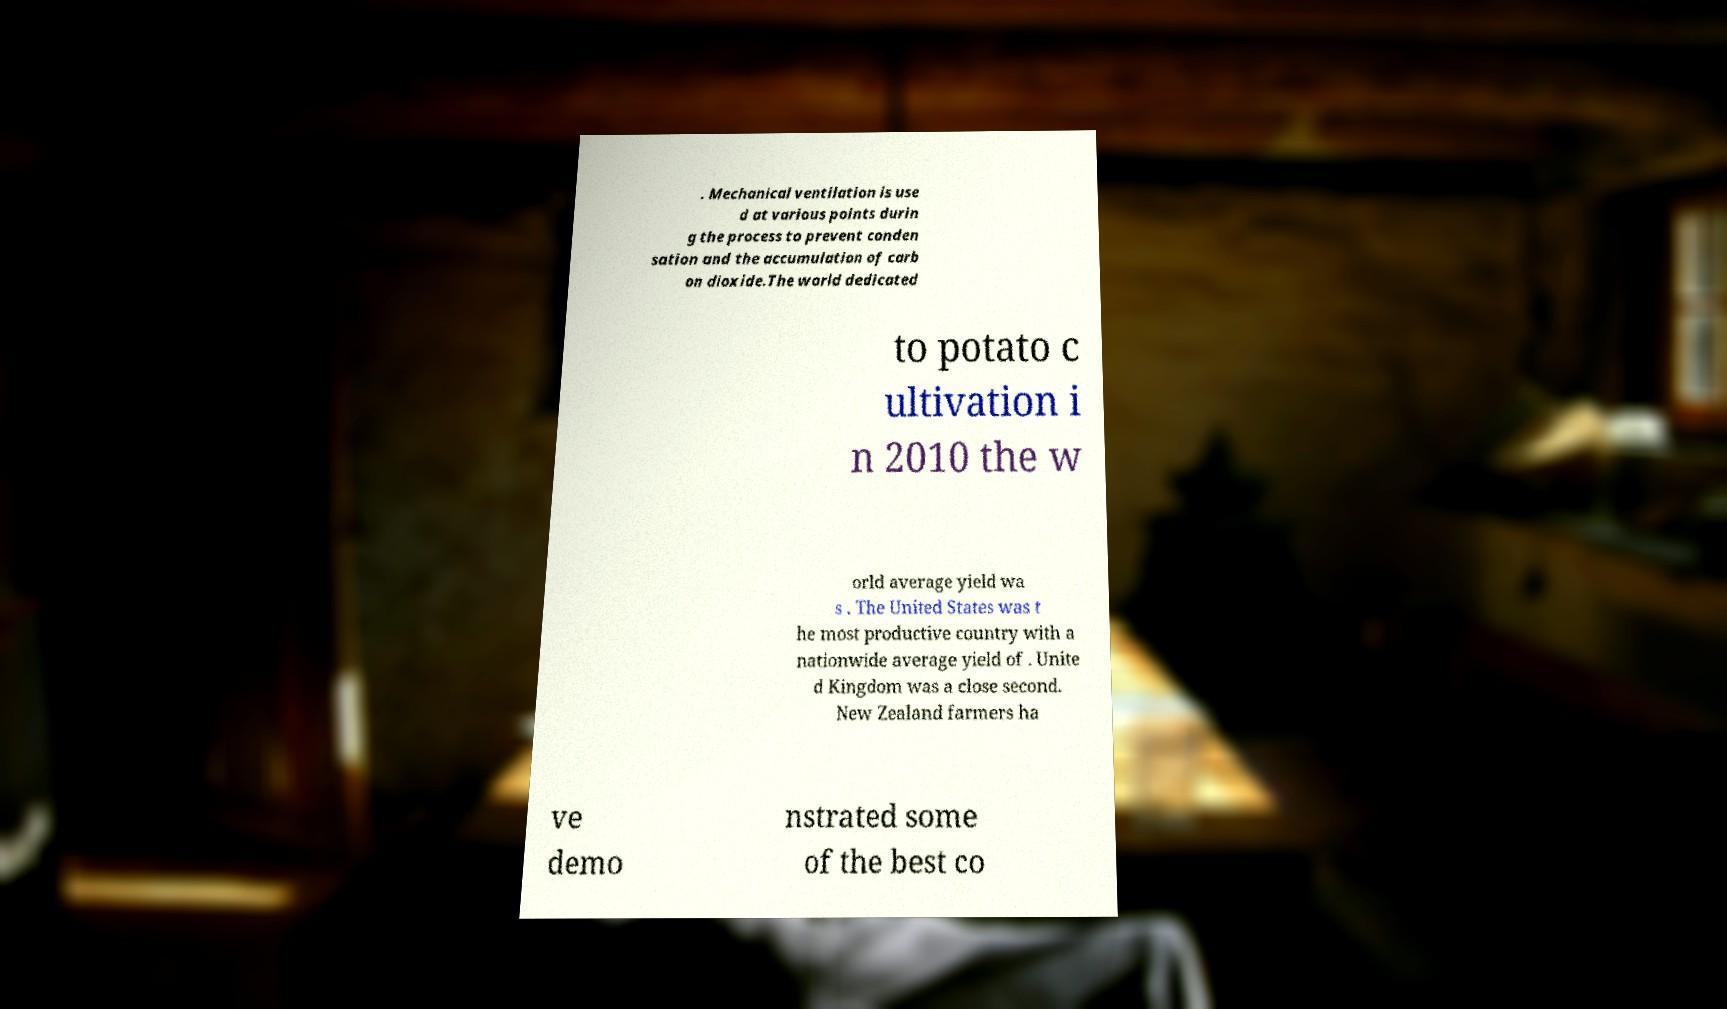Could you assist in decoding the text presented in this image and type it out clearly? . Mechanical ventilation is use d at various points durin g the process to prevent conden sation and the accumulation of carb on dioxide.The world dedicated to potato c ultivation i n 2010 the w orld average yield wa s . The United States was t he most productive country with a nationwide average yield of . Unite d Kingdom was a close second. New Zealand farmers ha ve demo nstrated some of the best co 